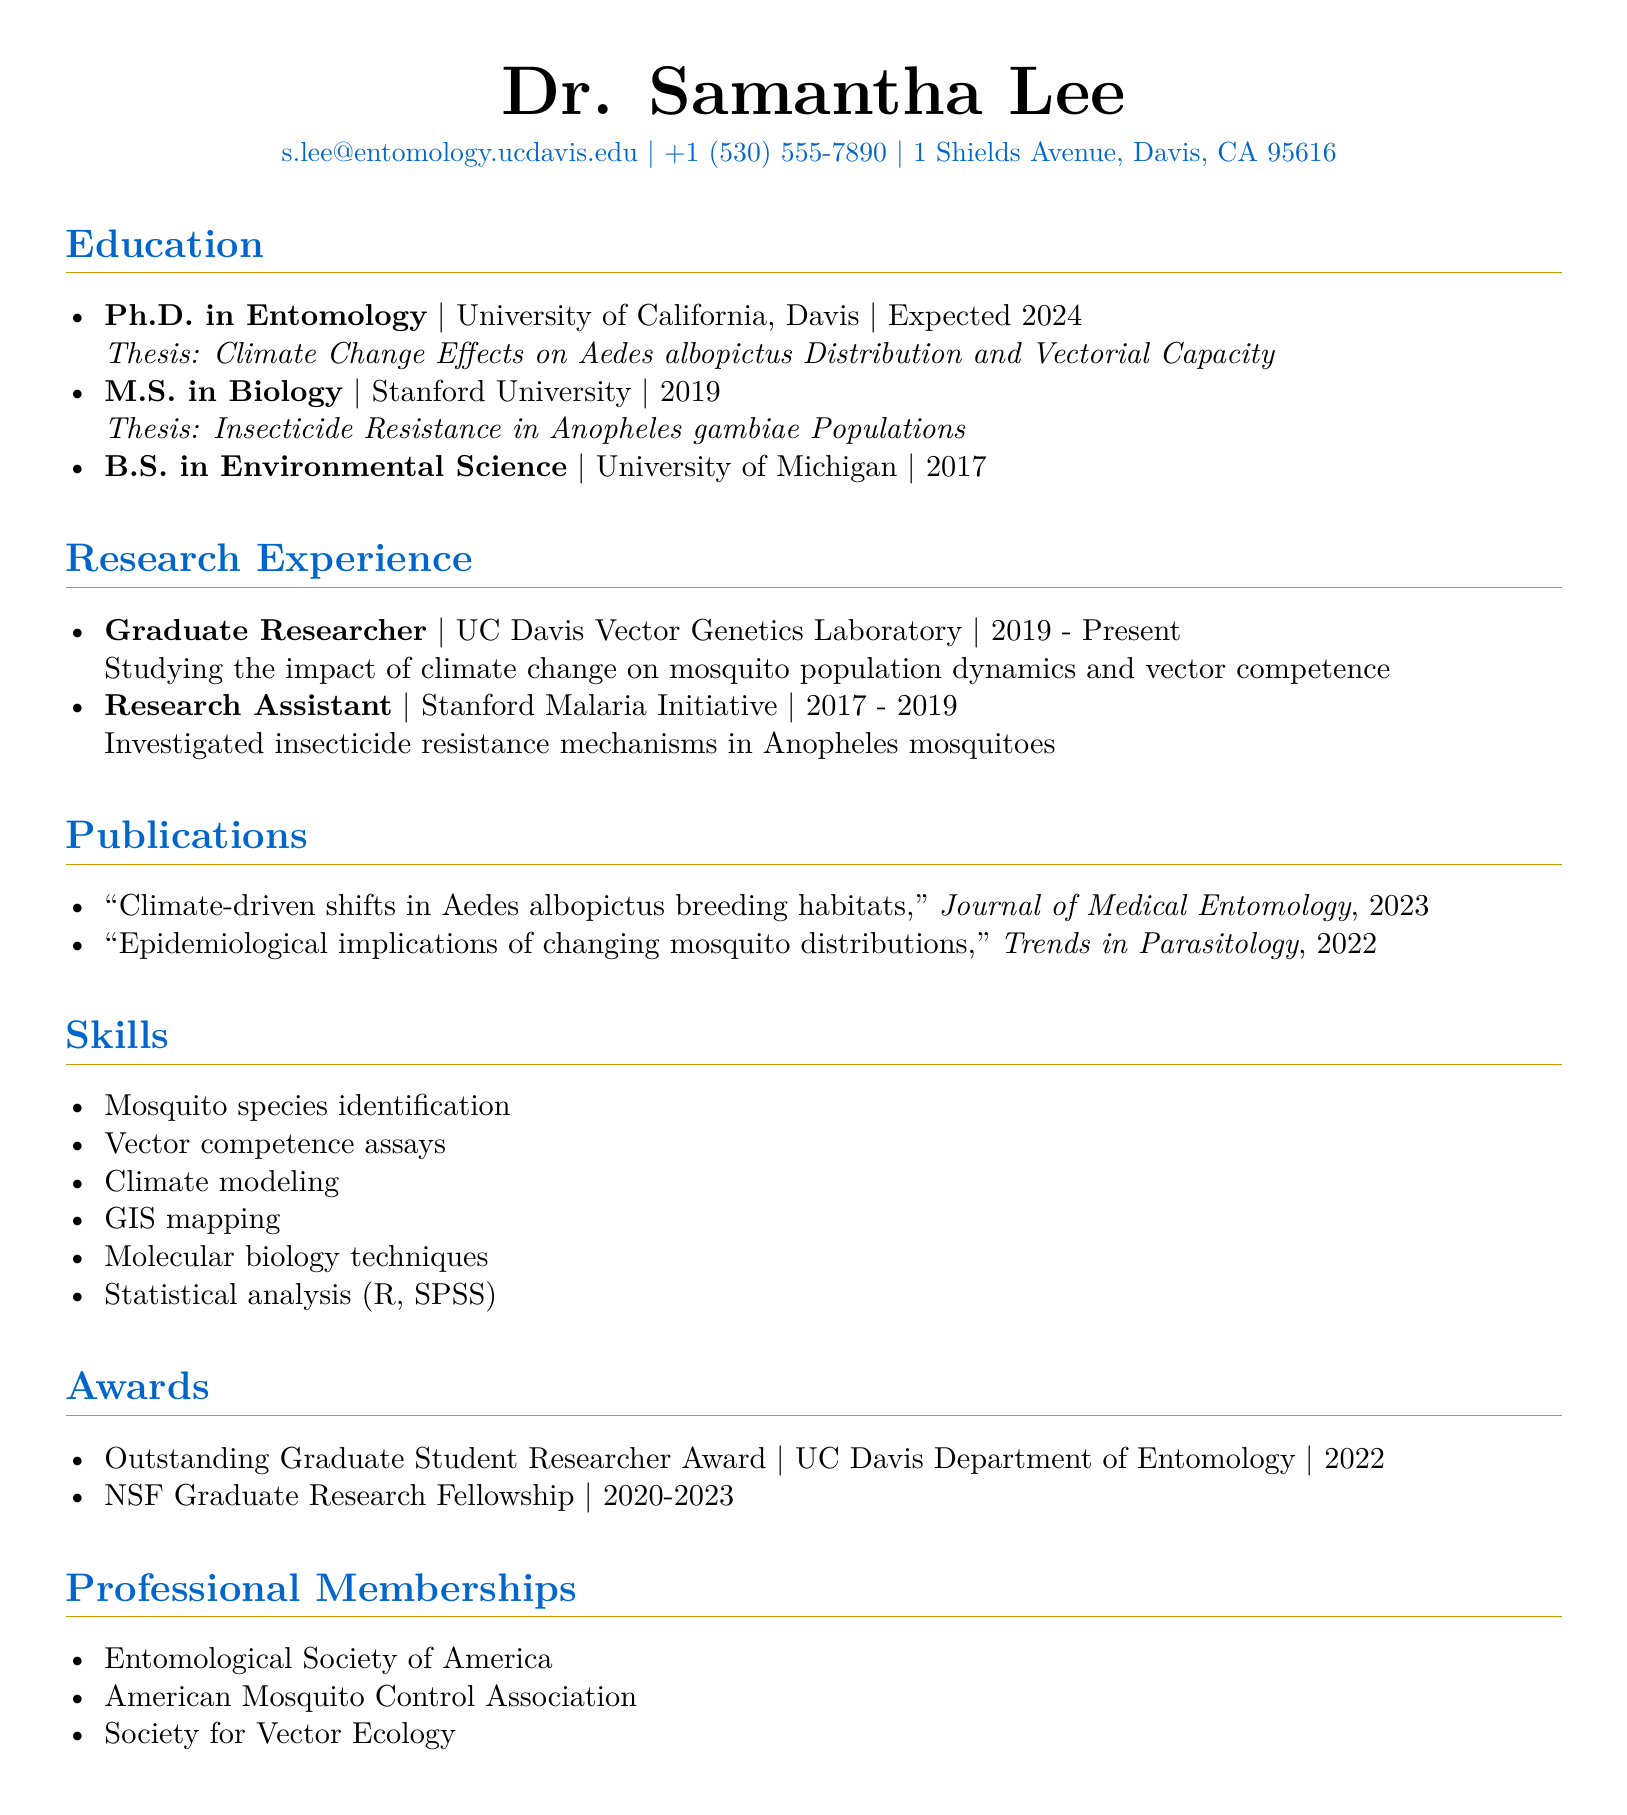what is Dr. Samantha Lee's email address? The email address is provided in the personal info section of the CV.
Answer: s.lee@entomology.ucdavis.edu what is the expected year of graduation for the Ph.D. in Entomology? The expected year of graduation is mentioned in the education section of the CV.
Answer: 2024 which institution awarded the Outstanding Graduate Student Researcher Award? This information is found in the awards section of the CV.
Answer: UC Davis Department of Entomology what is the title of Dr. Samantha Lee's thesis for her M.S. degree? The thesis title is listed under her education details for the M.S. degree.
Answer: Insecticide Resistance in Anopheles gambiae Populations what research focus is Dr. Samantha Lee currently pursuing? The research focus is described in detail in the research experience section.
Answer: Climate change on mosquito population dynamics and vector competence how many professional memberships does Dr. Samantha Lee hold? The total number of memberships is indicated in the professional memberships section of the CV.
Answer: 3 what type of modeling skills does Dr. Samantha Lee have? This skill is specified in the skills section of the CV.
Answer: Climate modeling who was Dr. Samantha Lee's thesis advisor for her B.S. degree? The CV does not provide specific information about her thesis advisor for the B.S. degree.
Answer: Not mentioned what are the start and end years of Dr. Samantha Lee's role as a Graduate Researcher? The start and end years can be found in the research experience section.
Answer: 2019 - Present 